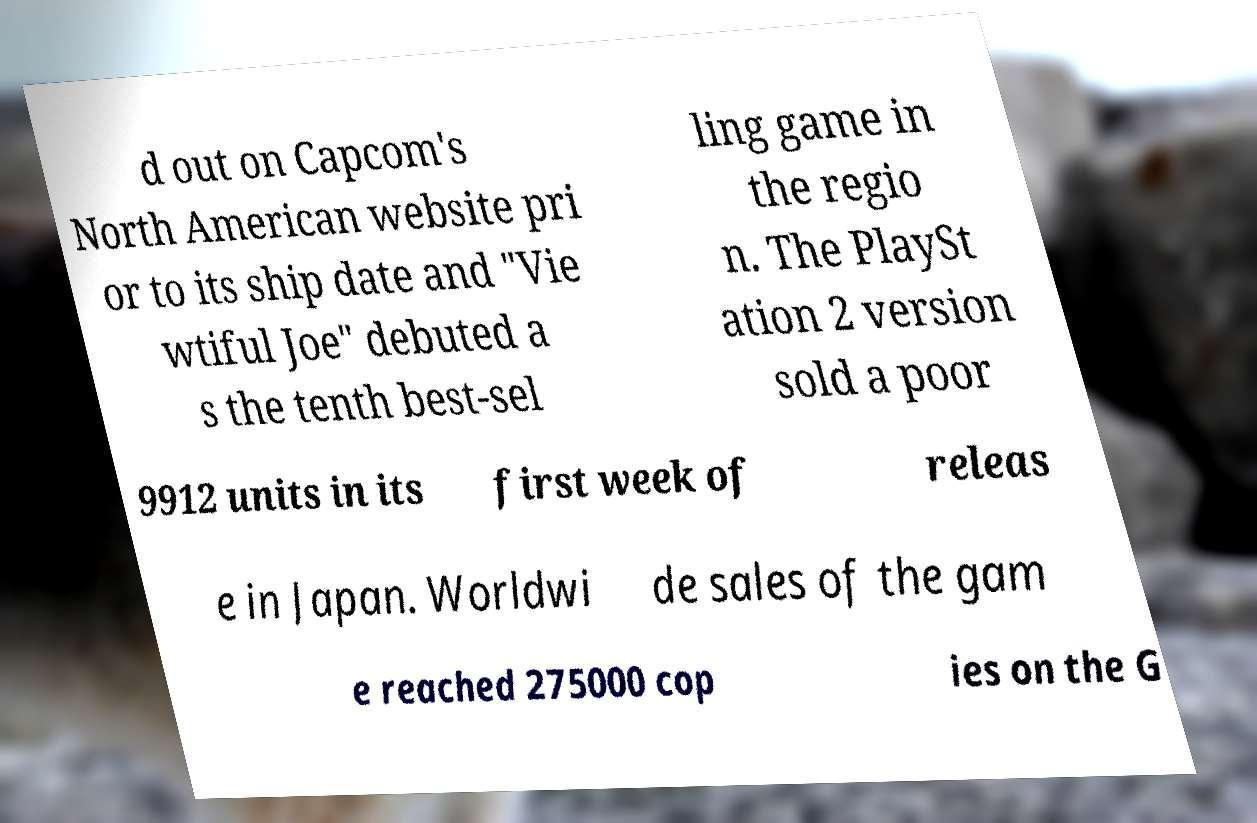I need the written content from this picture converted into text. Can you do that? d out on Capcom's North American website pri or to its ship date and "Vie wtiful Joe" debuted a s the tenth best-sel ling game in the regio n. The PlaySt ation 2 version sold a poor 9912 units in its first week of releas e in Japan. Worldwi de sales of the gam e reached 275000 cop ies on the G 